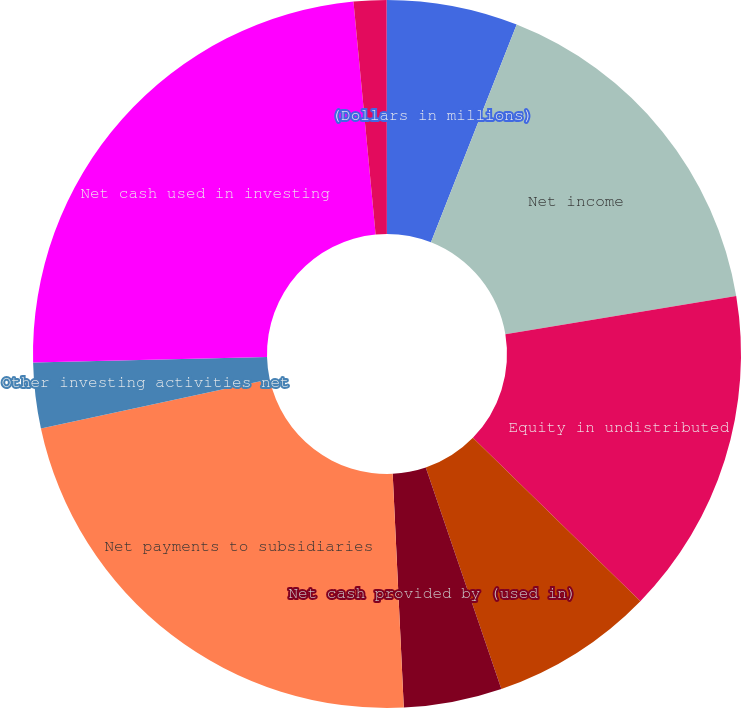Convert chart. <chart><loc_0><loc_0><loc_500><loc_500><pie_chart><fcel>(Dollars in millions)<fcel>Net income<fcel>Equity in undistributed<fcel>Other operating activities net<fcel>Net cash provided by (used in)<fcel>Net payments to subsidiaries<fcel>Other investing activities net<fcel>Net cash used in investing<fcel>Net decrease in short-term<fcel>Net increase (decrease) in<nl><fcel>5.97%<fcel>16.41%<fcel>14.92%<fcel>7.46%<fcel>4.48%<fcel>22.38%<fcel>2.99%<fcel>23.87%<fcel>1.5%<fcel>0.01%<nl></chart> 